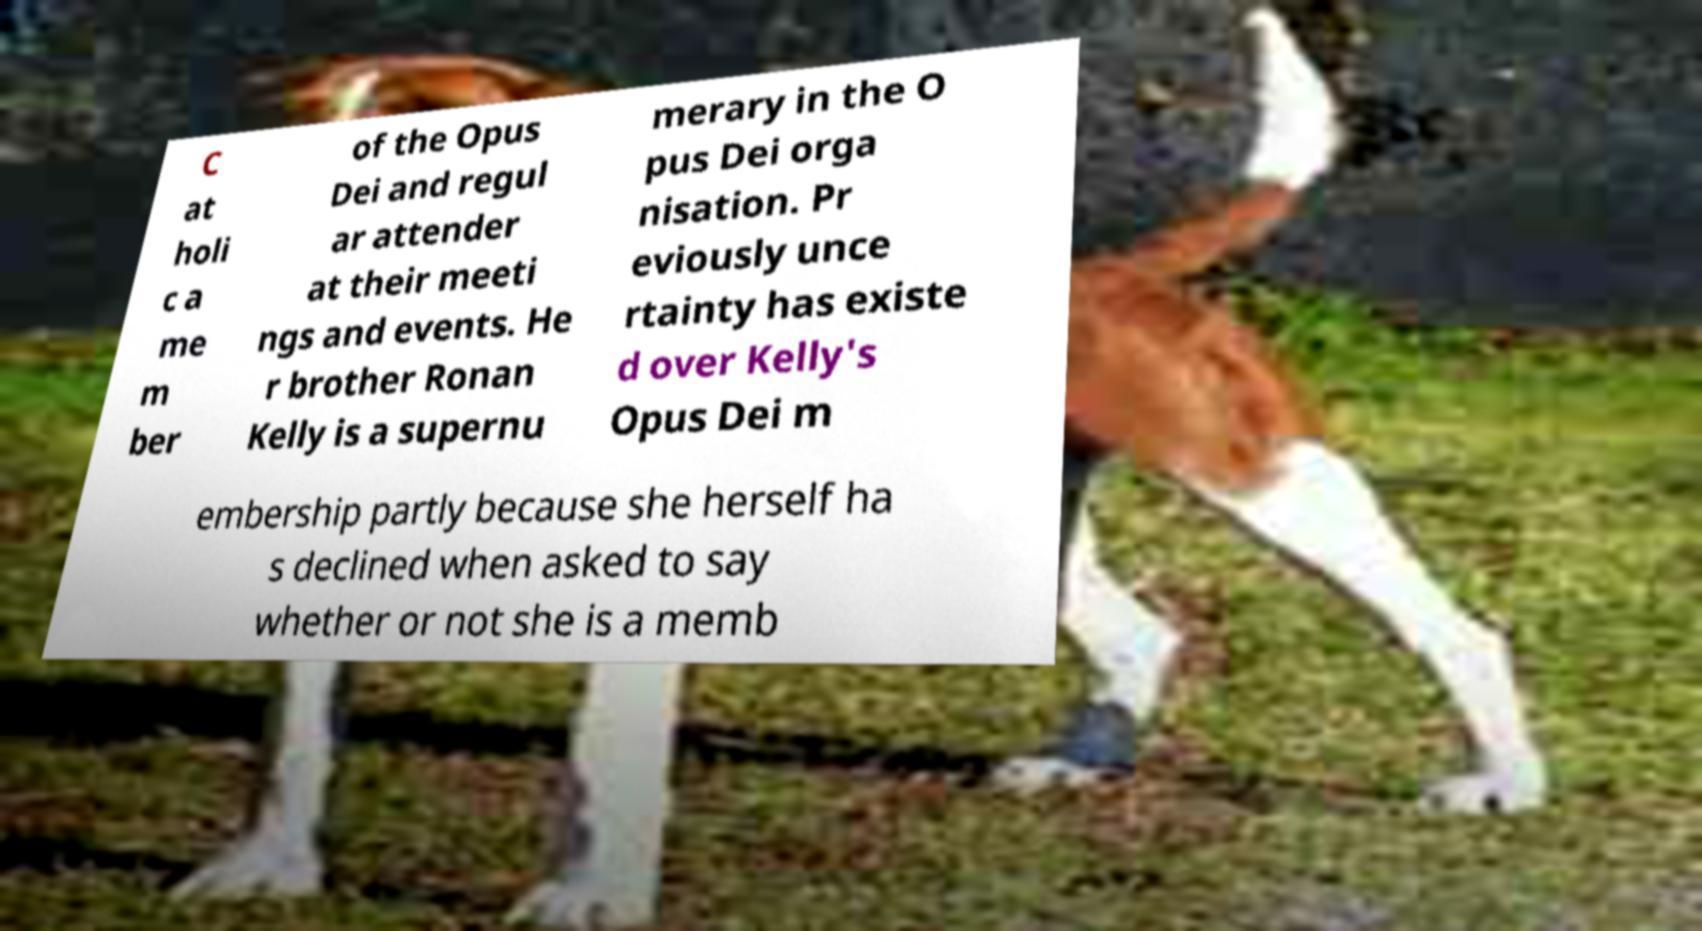I need the written content from this picture converted into text. Can you do that? C at holi c a me m ber of the Opus Dei and regul ar attender at their meeti ngs and events. He r brother Ronan Kelly is a supernu merary in the O pus Dei orga nisation. Pr eviously unce rtainty has existe d over Kelly's Opus Dei m embership partly because she herself ha s declined when asked to say whether or not she is a memb 